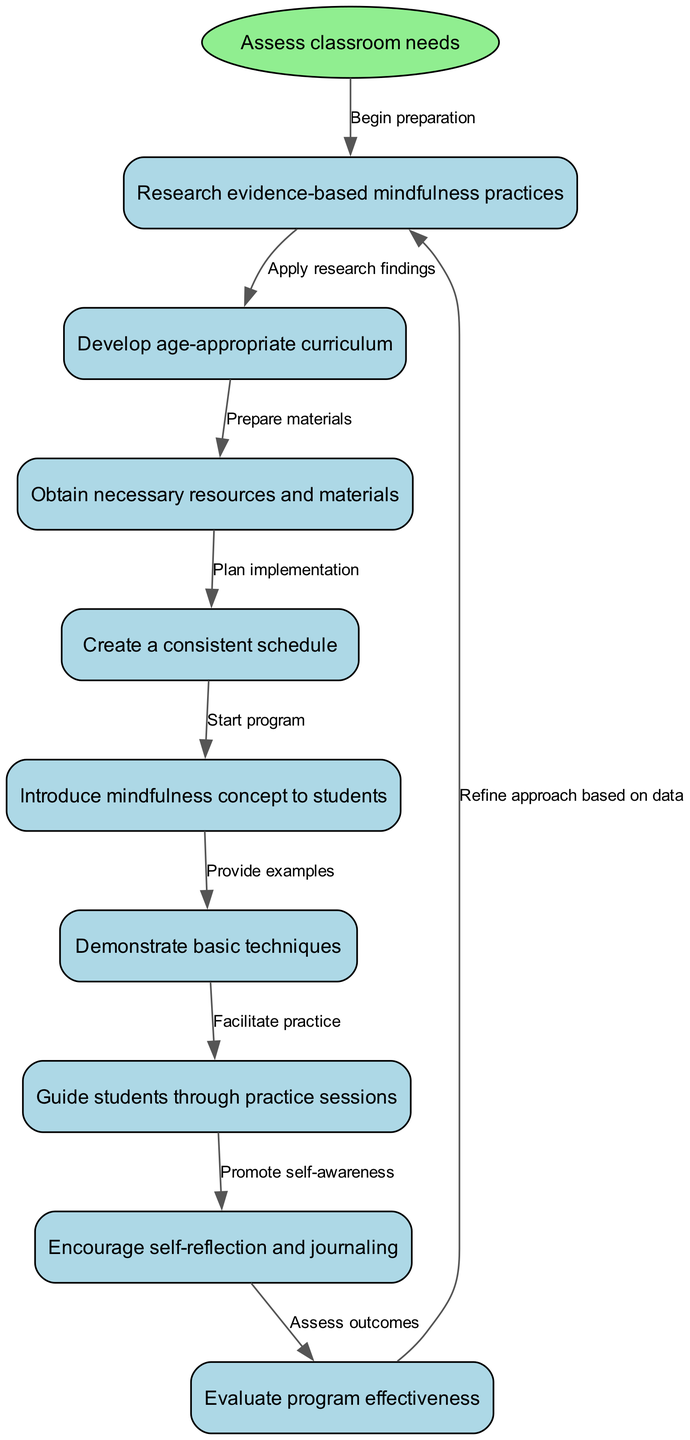What is the starting point of the program? The diagram indicates that the starting point is labeled "Assess classroom needs." This is the first node before any other actions can take place.
Answer: Assess classroom needs How many nodes are there in the flowchart? By counting the nodes in the diagram, there are a total of nine nodes representing different steps in the implementation of the mindfulness program.
Answer: Nine Which step follows "Research evidence-based mindfulness practices"? Referring to the flowchart, the step that directly follows "Research evidence-based mindfulness practices" is "Develop age-appropriate curriculum," as indicated by the edge connecting these two nodes.
Answer: Develop age-appropriate curriculum What is the last action taken in the program? The last action taken according to the diagram is "Evaluate program effectiveness," which indicates the conclusion of the mindfulness meditation program's steps.
Answer: Evaluate program effectiveness What is the connection type between "Guide students through practice sessions" and "Encourage self-reflection and journaling"? The connection between "Guide students through practice sessions" and "Encourage self-reflection and journaling" is labeled "Promote self-awareness," showing a direct flow from one activity to the next in the implementation process.
Answer: Promote self-awareness What happens after evaluating the program's effectiveness? After evaluating the program's effectiveness, the flowchart indicates that the next step is to "Refine approach based on data," which suggests an iterative process to improve the program.
Answer: Refine approach based on data What is the relationship between "Demonstrate basic techniques" and "Guide students through practice sessions"? The diagram illustrates that "Demonstrate basic techniques" leads to "Guide students through practice sessions," showing a sequential relationship where demonstration precedes student practice.
Answer: Demonstrate basic techniques leads to Guide students through practice sessions What step comes before obtaining necessary resources and materials? The step that comes before obtaining necessary resources and materials is "Develop age-appropriate curriculum," which is essential to determine the needed materials.
Answer: Develop age-appropriate curriculum 